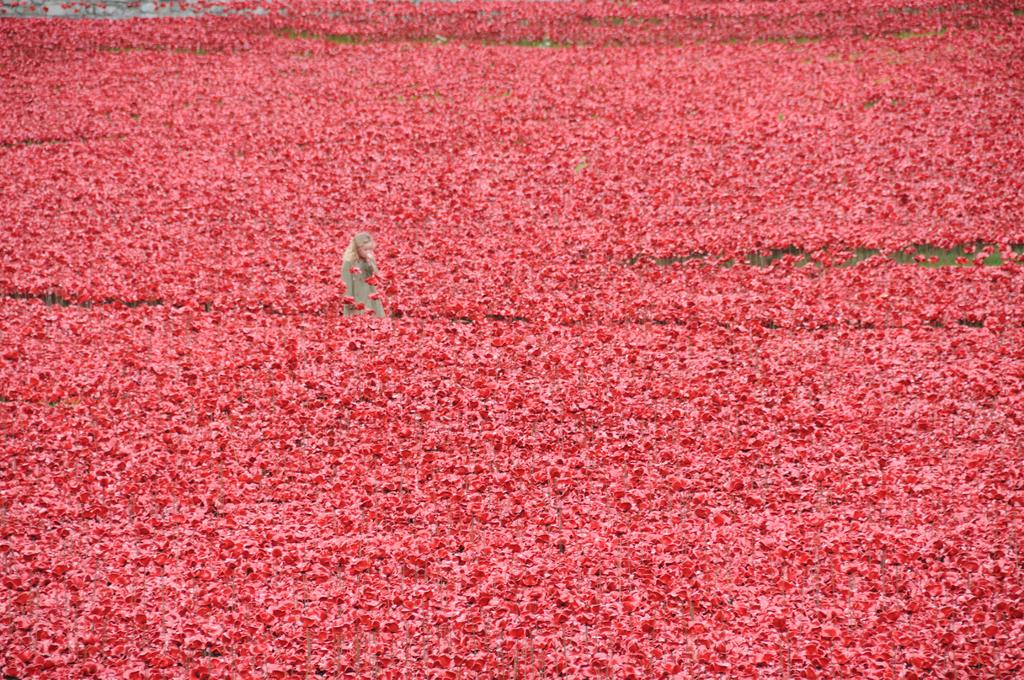What is the main subject of the image? There is a person standing in the image. Where is the person located in relation to the plants? The person is standing between plants. What color are the flowers on the plants? The flowers on the plants have a red color. What type of plate is being used to hold the person's attention in the image? There is no plate present in the image, and the person's attention is not being held by any object. What song is being played in the background of the image? There is no indication of any music or song being played in the image. 